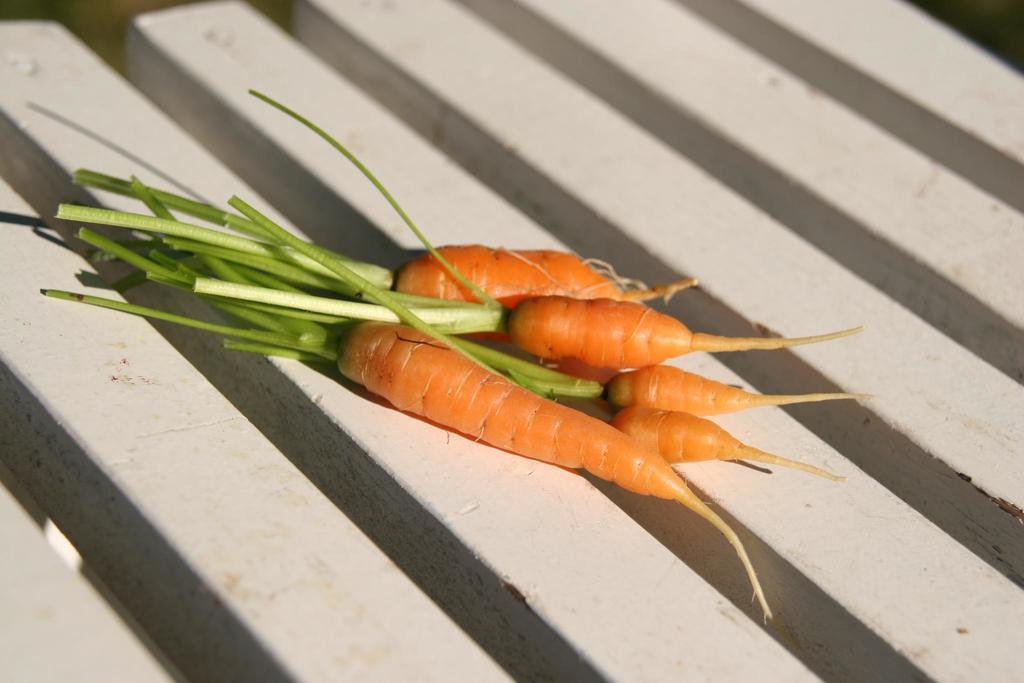Could you give a brief overview of what you see in this image? In this image I can see few carrots on the white color surface. I can see the black color background. 